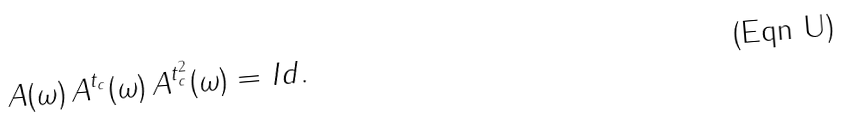Convert formula to latex. <formula><loc_0><loc_0><loc_500><loc_500>A ( \omega ) \, A ^ { t _ { c } } ( \omega ) \, A ^ { t _ { c } ^ { 2 } } ( \omega ) = { I d } .</formula> 